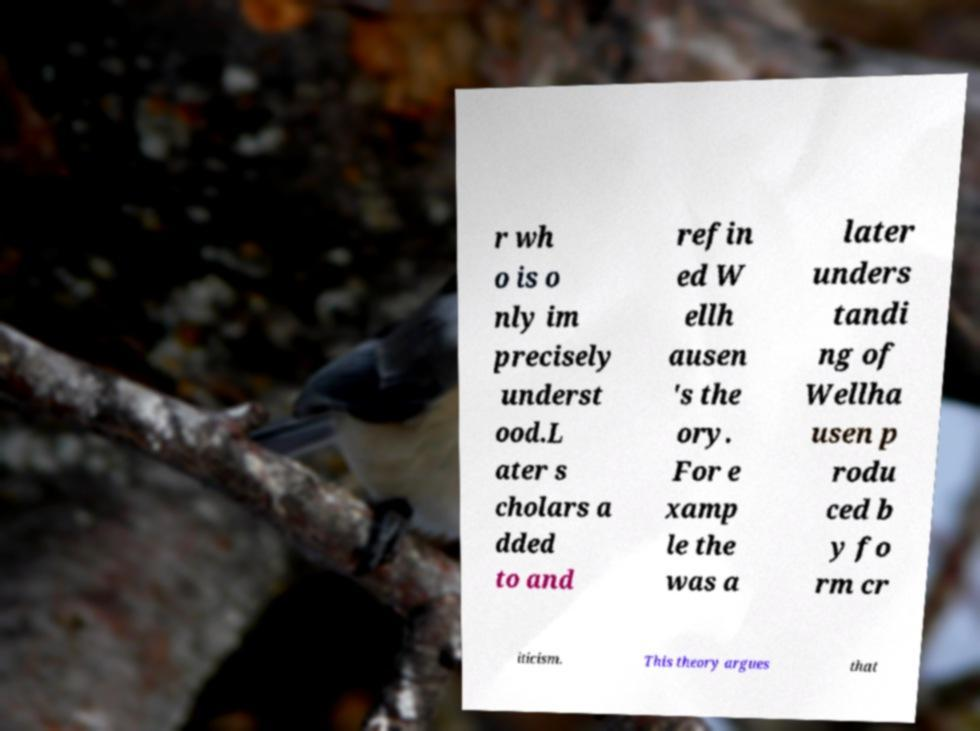Could you extract and type out the text from this image? r wh o is o nly im precisely underst ood.L ater s cholars a dded to and refin ed W ellh ausen 's the ory. For e xamp le the was a later unders tandi ng of Wellha usen p rodu ced b y fo rm cr iticism. This theory argues that 